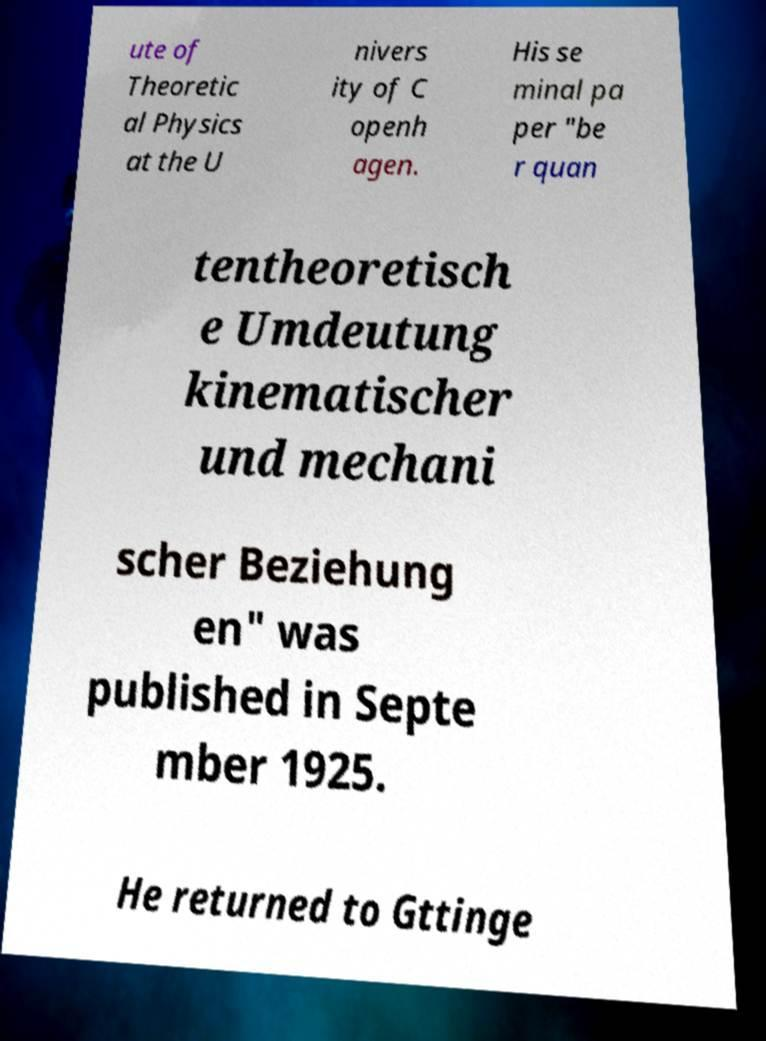There's text embedded in this image that I need extracted. Can you transcribe it verbatim? ute of Theoretic al Physics at the U nivers ity of C openh agen. His se minal pa per "be r quan tentheoretisch e Umdeutung kinematischer und mechani scher Beziehung en" was published in Septe mber 1925. He returned to Gttinge 